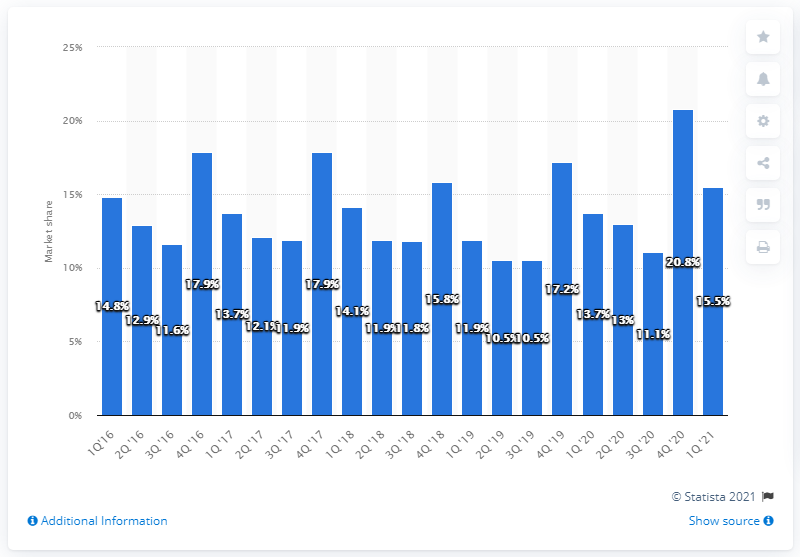Point out several critical features in this image. According to the first quarter of 2021, Apple claimed 15.5% of the smartphone market. According to recent market share data, Apple held a 20.8% share of the global smartphone market in the fourth quarter of 2021. 